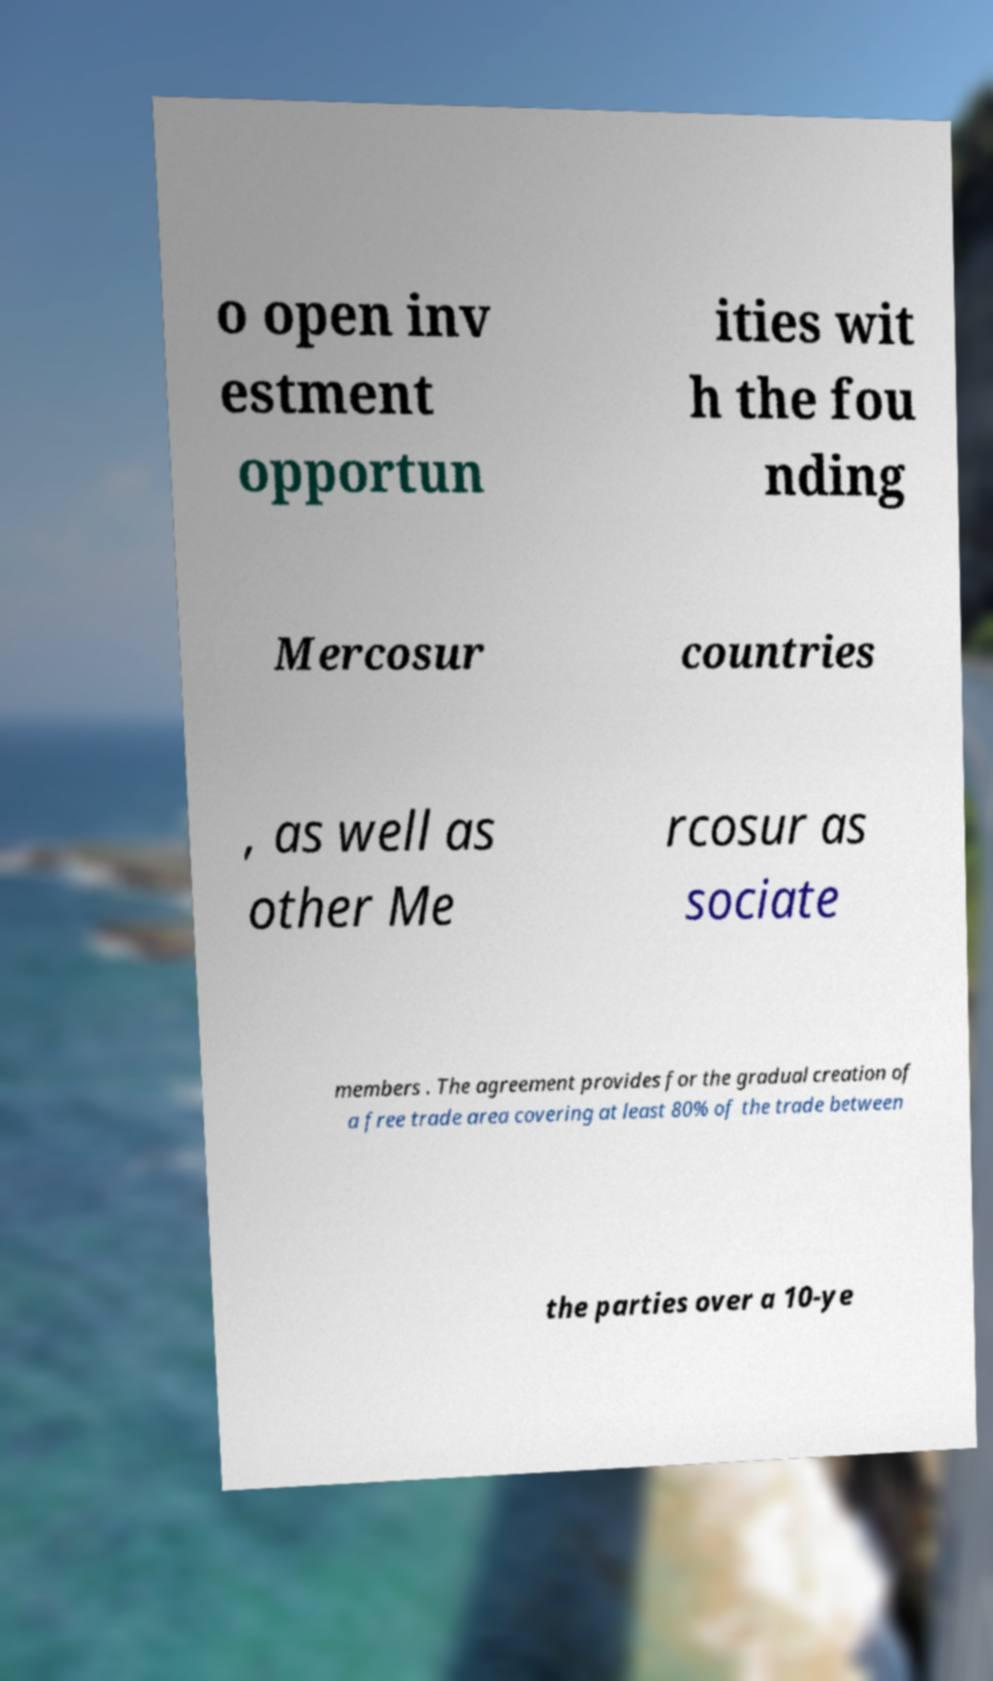Can you read and provide the text displayed in the image?This photo seems to have some interesting text. Can you extract and type it out for me? o open inv estment opportun ities wit h the fou nding Mercosur countries , as well as other Me rcosur as sociate members . The agreement provides for the gradual creation of a free trade area covering at least 80% of the trade between the parties over a 10-ye 